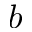Convert formula to latex. <formula><loc_0><loc_0><loc_500><loc_500>b</formula> 